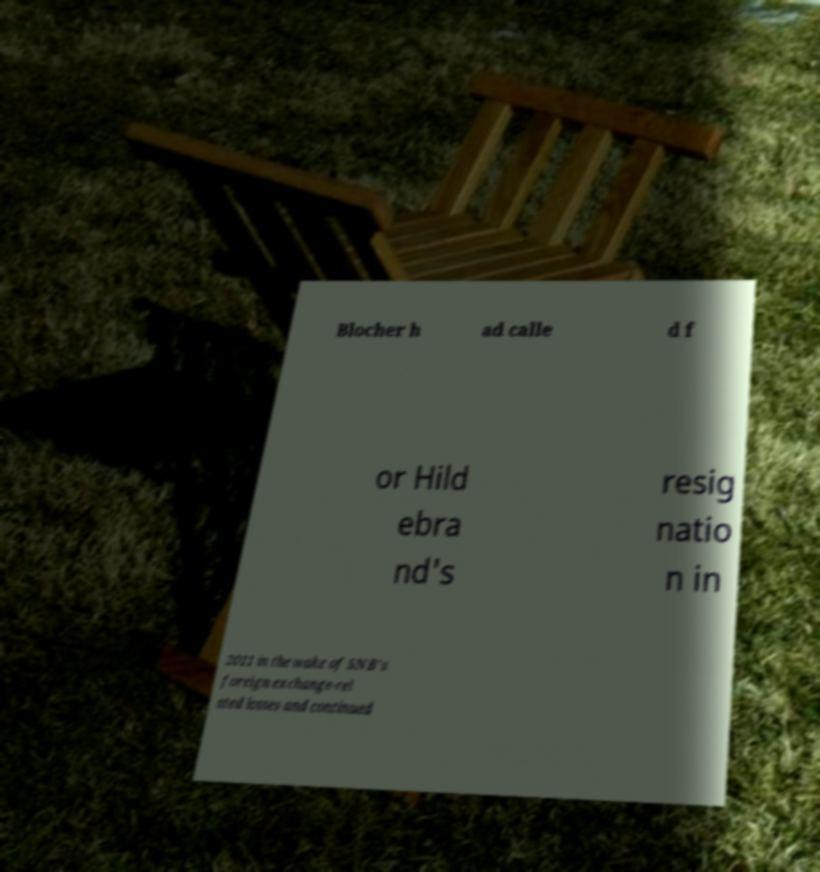Can you accurately transcribe the text from the provided image for me? Blocher h ad calle d f or Hild ebra nd's resig natio n in 2011 in the wake of SNB's foreign exchange-rel ated losses and continued 